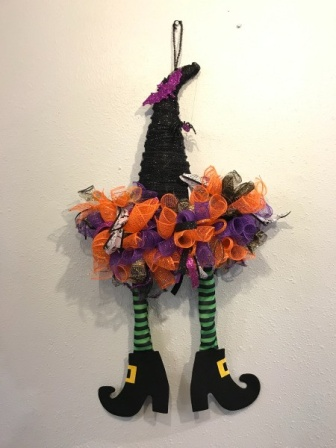What scene does this decoration remind you of? This whimsical decoration reminds me of the classic Halloween tale where witches zoom around on their broomsticks. It almost appears as though the witch was flying too fast and ended up stuck in the wall! This humorous scene brings to life the playful and mischievous side of Halloween folklore. What materials might have been used to create this decoration? The decoration likely uses a variety of materials to achieve its detailed appearance. The hat might be made from a sturdy fabric or felt, with a bright purple ribbon and shiny buckle affixed as accents. The mesh ribbons in orange and purple could be made from tulle or a similar lightweight fabric. The witch's legs are probably crafted from fabric or foam, and painted with the distinctive black and green stripes. The shoes might be made from a hard material like plastic or foam, painted black with gold buckles added for extra detail. Overall, a mix of textiles, synthetic materials, and decorative embellishments bring this festive creation to life. 